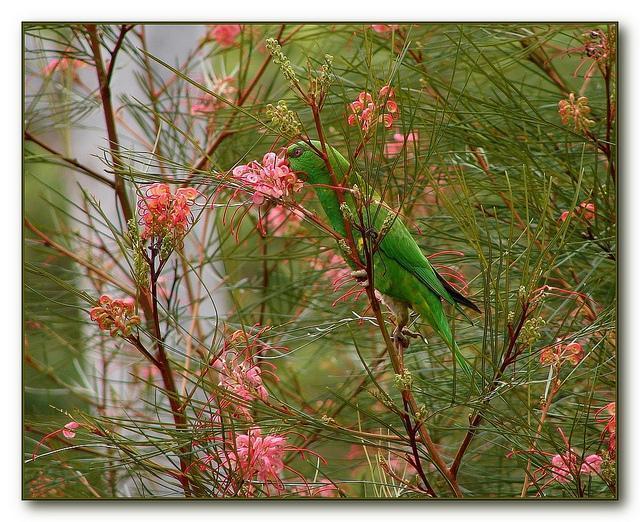How many birds are in the picture?
Give a very brief answer. 1. How many pieces of fruit in the bowl are green?
Give a very brief answer. 0. 